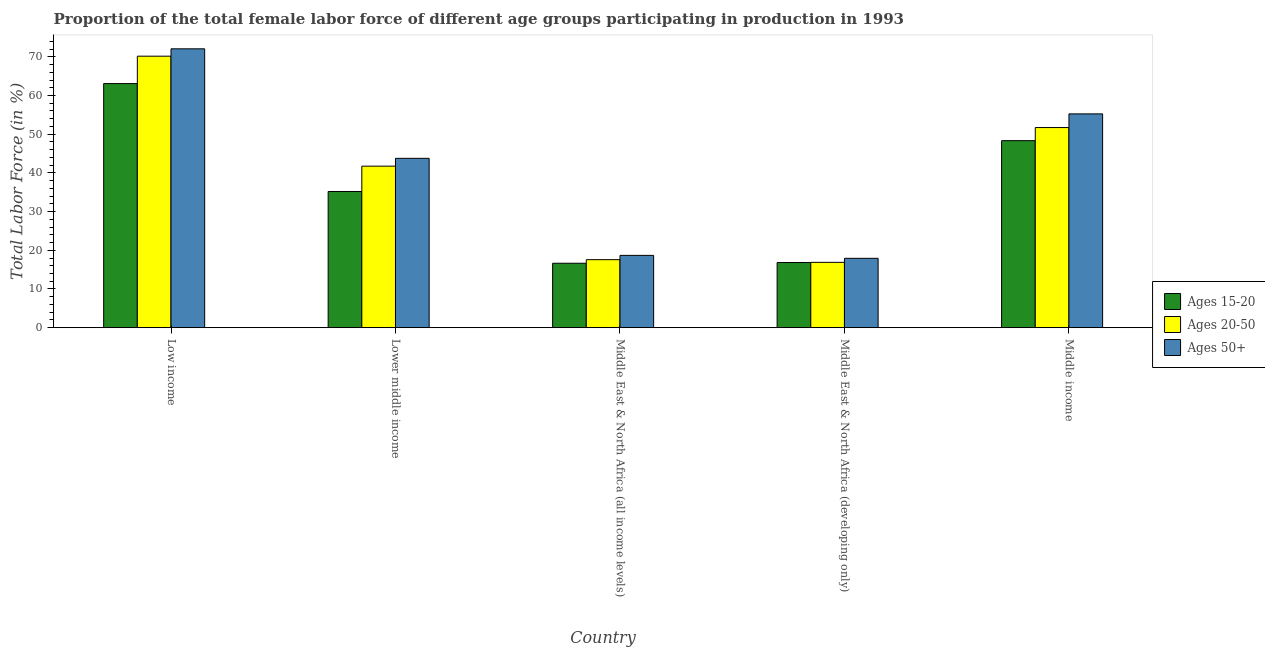How many different coloured bars are there?
Your answer should be very brief. 3. Are the number of bars per tick equal to the number of legend labels?
Your answer should be compact. Yes. What is the label of the 2nd group of bars from the left?
Your answer should be compact. Lower middle income. In how many cases, is the number of bars for a given country not equal to the number of legend labels?
Make the answer very short. 0. What is the percentage of female labor force within the age group 15-20 in Middle East & North Africa (developing only)?
Provide a succinct answer. 16.83. Across all countries, what is the maximum percentage of female labor force within the age group 15-20?
Give a very brief answer. 63.08. Across all countries, what is the minimum percentage of female labor force within the age group 15-20?
Provide a short and direct response. 16.65. In which country was the percentage of female labor force within the age group 20-50 minimum?
Provide a short and direct response. Middle East & North Africa (developing only). What is the total percentage of female labor force above age 50 in the graph?
Offer a terse response. 207.65. What is the difference between the percentage of female labor force within the age group 20-50 in Middle East & North Africa (all income levels) and that in Middle East & North Africa (developing only)?
Your response must be concise. 0.69. What is the difference between the percentage of female labor force above age 50 in Low income and the percentage of female labor force within the age group 15-20 in Middle East & North Africa (developing only)?
Offer a terse response. 55.23. What is the average percentage of female labor force within the age group 15-20 per country?
Give a very brief answer. 36.01. What is the difference between the percentage of female labor force above age 50 and percentage of female labor force within the age group 15-20 in Middle income?
Your response must be concise. 6.92. What is the ratio of the percentage of female labor force within the age group 20-50 in Low income to that in Middle East & North Africa (developing only)?
Your answer should be very brief. 4.16. What is the difference between the highest and the second highest percentage of female labor force within the age group 15-20?
Your answer should be very brief. 14.75. What is the difference between the highest and the lowest percentage of female labor force within the age group 15-20?
Your response must be concise. 46.43. Is the sum of the percentage of female labor force above age 50 in Middle East & North Africa (all income levels) and Middle income greater than the maximum percentage of female labor force within the age group 15-20 across all countries?
Provide a short and direct response. Yes. What does the 1st bar from the left in Lower middle income represents?
Give a very brief answer. Ages 15-20. What does the 3rd bar from the right in Low income represents?
Offer a very short reply. Ages 15-20. Is it the case that in every country, the sum of the percentage of female labor force within the age group 15-20 and percentage of female labor force within the age group 20-50 is greater than the percentage of female labor force above age 50?
Keep it short and to the point. Yes. How many bars are there?
Ensure brevity in your answer.  15. How many countries are there in the graph?
Offer a very short reply. 5. Are the values on the major ticks of Y-axis written in scientific E-notation?
Offer a very short reply. No. Does the graph contain grids?
Keep it short and to the point. No. How are the legend labels stacked?
Your answer should be very brief. Vertical. What is the title of the graph?
Your answer should be very brief. Proportion of the total female labor force of different age groups participating in production in 1993. Does "Central government" appear as one of the legend labels in the graph?
Provide a short and direct response. No. What is the label or title of the X-axis?
Ensure brevity in your answer.  Country. What is the label or title of the Y-axis?
Provide a short and direct response. Total Labor Force (in %). What is the Total Labor Force (in %) in Ages 15-20 in Low income?
Your answer should be compact. 63.08. What is the Total Labor Force (in %) in Ages 20-50 in Low income?
Ensure brevity in your answer.  70.16. What is the Total Labor Force (in %) of Ages 50+ in Low income?
Your response must be concise. 72.06. What is the Total Labor Force (in %) in Ages 15-20 in Lower middle income?
Your answer should be very brief. 35.19. What is the Total Labor Force (in %) of Ages 20-50 in Lower middle income?
Ensure brevity in your answer.  41.74. What is the Total Labor Force (in %) in Ages 50+ in Lower middle income?
Offer a very short reply. 43.76. What is the Total Labor Force (in %) in Ages 15-20 in Middle East & North Africa (all income levels)?
Your answer should be compact. 16.65. What is the Total Labor Force (in %) of Ages 20-50 in Middle East & North Africa (all income levels)?
Give a very brief answer. 17.57. What is the Total Labor Force (in %) of Ages 50+ in Middle East & North Africa (all income levels)?
Offer a very short reply. 18.68. What is the Total Labor Force (in %) in Ages 15-20 in Middle East & North Africa (developing only)?
Your response must be concise. 16.83. What is the Total Labor Force (in %) of Ages 20-50 in Middle East & North Africa (developing only)?
Make the answer very short. 16.88. What is the Total Labor Force (in %) in Ages 50+ in Middle East & North Africa (developing only)?
Make the answer very short. 17.92. What is the Total Labor Force (in %) in Ages 15-20 in Middle income?
Offer a terse response. 48.32. What is the Total Labor Force (in %) in Ages 20-50 in Middle income?
Give a very brief answer. 51.71. What is the Total Labor Force (in %) of Ages 50+ in Middle income?
Offer a terse response. 55.24. Across all countries, what is the maximum Total Labor Force (in %) in Ages 15-20?
Provide a short and direct response. 63.08. Across all countries, what is the maximum Total Labor Force (in %) of Ages 20-50?
Offer a very short reply. 70.16. Across all countries, what is the maximum Total Labor Force (in %) in Ages 50+?
Offer a terse response. 72.06. Across all countries, what is the minimum Total Labor Force (in %) of Ages 15-20?
Offer a very short reply. 16.65. Across all countries, what is the minimum Total Labor Force (in %) in Ages 20-50?
Your answer should be very brief. 16.88. Across all countries, what is the minimum Total Labor Force (in %) in Ages 50+?
Your answer should be very brief. 17.92. What is the total Total Labor Force (in %) of Ages 15-20 in the graph?
Provide a succinct answer. 180.07. What is the total Total Labor Force (in %) of Ages 20-50 in the graph?
Offer a very short reply. 198.06. What is the total Total Labor Force (in %) in Ages 50+ in the graph?
Make the answer very short. 207.65. What is the difference between the Total Labor Force (in %) in Ages 15-20 in Low income and that in Lower middle income?
Your answer should be compact. 27.89. What is the difference between the Total Labor Force (in %) of Ages 20-50 in Low income and that in Lower middle income?
Provide a succinct answer. 28.42. What is the difference between the Total Labor Force (in %) in Ages 50+ in Low income and that in Lower middle income?
Provide a succinct answer. 28.3. What is the difference between the Total Labor Force (in %) in Ages 15-20 in Low income and that in Middle East & North Africa (all income levels)?
Your response must be concise. 46.43. What is the difference between the Total Labor Force (in %) of Ages 20-50 in Low income and that in Middle East & North Africa (all income levels)?
Keep it short and to the point. 52.59. What is the difference between the Total Labor Force (in %) in Ages 50+ in Low income and that in Middle East & North Africa (all income levels)?
Your response must be concise. 53.38. What is the difference between the Total Labor Force (in %) of Ages 15-20 in Low income and that in Middle East & North Africa (developing only)?
Give a very brief answer. 46.25. What is the difference between the Total Labor Force (in %) of Ages 20-50 in Low income and that in Middle East & North Africa (developing only)?
Give a very brief answer. 53.28. What is the difference between the Total Labor Force (in %) in Ages 50+ in Low income and that in Middle East & North Africa (developing only)?
Offer a terse response. 54.14. What is the difference between the Total Labor Force (in %) in Ages 15-20 in Low income and that in Middle income?
Offer a terse response. 14.75. What is the difference between the Total Labor Force (in %) of Ages 20-50 in Low income and that in Middle income?
Your answer should be very brief. 18.45. What is the difference between the Total Labor Force (in %) in Ages 50+ in Low income and that in Middle income?
Your answer should be very brief. 16.81. What is the difference between the Total Labor Force (in %) of Ages 15-20 in Lower middle income and that in Middle East & North Africa (all income levels)?
Your response must be concise. 18.54. What is the difference between the Total Labor Force (in %) of Ages 20-50 in Lower middle income and that in Middle East & North Africa (all income levels)?
Provide a succinct answer. 24.17. What is the difference between the Total Labor Force (in %) in Ages 50+ in Lower middle income and that in Middle East & North Africa (all income levels)?
Provide a short and direct response. 25.08. What is the difference between the Total Labor Force (in %) in Ages 15-20 in Lower middle income and that in Middle East & North Africa (developing only)?
Give a very brief answer. 18.36. What is the difference between the Total Labor Force (in %) in Ages 20-50 in Lower middle income and that in Middle East & North Africa (developing only)?
Ensure brevity in your answer.  24.86. What is the difference between the Total Labor Force (in %) of Ages 50+ in Lower middle income and that in Middle East & North Africa (developing only)?
Your answer should be compact. 25.84. What is the difference between the Total Labor Force (in %) of Ages 15-20 in Lower middle income and that in Middle income?
Keep it short and to the point. -13.14. What is the difference between the Total Labor Force (in %) of Ages 20-50 in Lower middle income and that in Middle income?
Provide a short and direct response. -9.97. What is the difference between the Total Labor Force (in %) of Ages 50+ in Lower middle income and that in Middle income?
Make the answer very short. -11.49. What is the difference between the Total Labor Force (in %) in Ages 15-20 in Middle East & North Africa (all income levels) and that in Middle East & North Africa (developing only)?
Offer a terse response. -0.18. What is the difference between the Total Labor Force (in %) of Ages 20-50 in Middle East & North Africa (all income levels) and that in Middle East & North Africa (developing only)?
Provide a succinct answer. 0.69. What is the difference between the Total Labor Force (in %) of Ages 50+ in Middle East & North Africa (all income levels) and that in Middle East & North Africa (developing only)?
Your answer should be very brief. 0.76. What is the difference between the Total Labor Force (in %) of Ages 15-20 in Middle East & North Africa (all income levels) and that in Middle income?
Give a very brief answer. -31.68. What is the difference between the Total Labor Force (in %) of Ages 20-50 in Middle East & North Africa (all income levels) and that in Middle income?
Provide a short and direct response. -34.14. What is the difference between the Total Labor Force (in %) in Ages 50+ in Middle East & North Africa (all income levels) and that in Middle income?
Provide a short and direct response. -36.57. What is the difference between the Total Labor Force (in %) of Ages 15-20 in Middle East & North Africa (developing only) and that in Middle income?
Provide a short and direct response. -31.49. What is the difference between the Total Labor Force (in %) of Ages 20-50 in Middle East & North Africa (developing only) and that in Middle income?
Your response must be concise. -34.83. What is the difference between the Total Labor Force (in %) in Ages 50+ in Middle East & North Africa (developing only) and that in Middle income?
Give a very brief answer. -37.32. What is the difference between the Total Labor Force (in %) of Ages 15-20 in Low income and the Total Labor Force (in %) of Ages 20-50 in Lower middle income?
Provide a succinct answer. 21.34. What is the difference between the Total Labor Force (in %) of Ages 15-20 in Low income and the Total Labor Force (in %) of Ages 50+ in Lower middle income?
Give a very brief answer. 19.32. What is the difference between the Total Labor Force (in %) in Ages 20-50 in Low income and the Total Labor Force (in %) in Ages 50+ in Lower middle income?
Your answer should be very brief. 26.4. What is the difference between the Total Labor Force (in %) in Ages 15-20 in Low income and the Total Labor Force (in %) in Ages 20-50 in Middle East & North Africa (all income levels)?
Your response must be concise. 45.51. What is the difference between the Total Labor Force (in %) in Ages 15-20 in Low income and the Total Labor Force (in %) in Ages 50+ in Middle East & North Africa (all income levels)?
Your response must be concise. 44.4. What is the difference between the Total Labor Force (in %) in Ages 20-50 in Low income and the Total Labor Force (in %) in Ages 50+ in Middle East & North Africa (all income levels)?
Your answer should be compact. 51.48. What is the difference between the Total Labor Force (in %) in Ages 15-20 in Low income and the Total Labor Force (in %) in Ages 20-50 in Middle East & North Africa (developing only)?
Give a very brief answer. 46.2. What is the difference between the Total Labor Force (in %) of Ages 15-20 in Low income and the Total Labor Force (in %) of Ages 50+ in Middle East & North Africa (developing only)?
Offer a terse response. 45.16. What is the difference between the Total Labor Force (in %) of Ages 20-50 in Low income and the Total Labor Force (in %) of Ages 50+ in Middle East & North Africa (developing only)?
Keep it short and to the point. 52.24. What is the difference between the Total Labor Force (in %) of Ages 15-20 in Low income and the Total Labor Force (in %) of Ages 20-50 in Middle income?
Offer a very short reply. 11.37. What is the difference between the Total Labor Force (in %) in Ages 15-20 in Low income and the Total Labor Force (in %) in Ages 50+ in Middle income?
Give a very brief answer. 7.83. What is the difference between the Total Labor Force (in %) in Ages 20-50 in Low income and the Total Labor Force (in %) in Ages 50+ in Middle income?
Your answer should be very brief. 14.91. What is the difference between the Total Labor Force (in %) of Ages 15-20 in Lower middle income and the Total Labor Force (in %) of Ages 20-50 in Middle East & North Africa (all income levels)?
Your answer should be compact. 17.62. What is the difference between the Total Labor Force (in %) in Ages 15-20 in Lower middle income and the Total Labor Force (in %) in Ages 50+ in Middle East & North Africa (all income levels)?
Offer a terse response. 16.51. What is the difference between the Total Labor Force (in %) of Ages 20-50 in Lower middle income and the Total Labor Force (in %) of Ages 50+ in Middle East & North Africa (all income levels)?
Provide a succinct answer. 23.06. What is the difference between the Total Labor Force (in %) of Ages 15-20 in Lower middle income and the Total Labor Force (in %) of Ages 20-50 in Middle East & North Africa (developing only)?
Keep it short and to the point. 18.31. What is the difference between the Total Labor Force (in %) of Ages 15-20 in Lower middle income and the Total Labor Force (in %) of Ages 50+ in Middle East & North Africa (developing only)?
Keep it short and to the point. 17.27. What is the difference between the Total Labor Force (in %) in Ages 20-50 in Lower middle income and the Total Labor Force (in %) in Ages 50+ in Middle East & North Africa (developing only)?
Give a very brief answer. 23.82. What is the difference between the Total Labor Force (in %) in Ages 15-20 in Lower middle income and the Total Labor Force (in %) in Ages 20-50 in Middle income?
Offer a terse response. -16.52. What is the difference between the Total Labor Force (in %) in Ages 15-20 in Lower middle income and the Total Labor Force (in %) in Ages 50+ in Middle income?
Provide a succinct answer. -20.06. What is the difference between the Total Labor Force (in %) of Ages 20-50 in Lower middle income and the Total Labor Force (in %) of Ages 50+ in Middle income?
Give a very brief answer. -13.5. What is the difference between the Total Labor Force (in %) in Ages 15-20 in Middle East & North Africa (all income levels) and the Total Labor Force (in %) in Ages 20-50 in Middle East & North Africa (developing only)?
Offer a very short reply. -0.23. What is the difference between the Total Labor Force (in %) of Ages 15-20 in Middle East & North Africa (all income levels) and the Total Labor Force (in %) of Ages 50+ in Middle East & North Africa (developing only)?
Offer a terse response. -1.27. What is the difference between the Total Labor Force (in %) of Ages 20-50 in Middle East & North Africa (all income levels) and the Total Labor Force (in %) of Ages 50+ in Middle East & North Africa (developing only)?
Offer a terse response. -0.35. What is the difference between the Total Labor Force (in %) in Ages 15-20 in Middle East & North Africa (all income levels) and the Total Labor Force (in %) in Ages 20-50 in Middle income?
Offer a very short reply. -35.06. What is the difference between the Total Labor Force (in %) of Ages 15-20 in Middle East & North Africa (all income levels) and the Total Labor Force (in %) of Ages 50+ in Middle income?
Give a very brief answer. -38.6. What is the difference between the Total Labor Force (in %) in Ages 20-50 in Middle East & North Africa (all income levels) and the Total Labor Force (in %) in Ages 50+ in Middle income?
Your response must be concise. -37.67. What is the difference between the Total Labor Force (in %) in Ages 15-20 in Middle East & North Africa (developing only) and the Total Labor Force (in %) in Ages 20-50 in Middle income?
Provide a succinct answer. -34.88. What is the difference between the Total Labor Force (in %) of Ages 15-20 in Middle East & North Africa (developing only) and the Total Labor Force (in %) of Ages 50+ in Middle income?
Your response must be concise. -38.41. What is the difference between the Total Labor Force (in %) of Ages 20-50 in Middle East & North Africa (developing only) and the Total Labor Force (in %) of Ages 50+ in Middle income?
Offer a very short reply. -38.37. What is the average Total Labor Force (in %) in Ages 15-20 per country?
Provide a succinct answer. 36.01. What is the average Total Labor Force (in %) in Ages 20-50 per country?
Offer a very short reply. 39.61. What is the average Total Labor Force (in %) in Ages 50+ per country?
Provide a succinct answer. 41.53. What is the difference between the Total Labor Force (in %) of Ages 15-20 and Total Labor Force (in %) of Ages 20-50 in Low income?
Keep it short and to the point. -7.08. What is the difference between the Total Labor Force (in %) of Ages 15-20 and Total Labor Force (in %) of Ages 50+ in Low income?
Make the answer very short. -8.98. What is the difference between the Total Labor Force (in %) in Ages 20-50 and Total Labor Force (in %) in Ages 50+ in Low income?
Make the answer very short. -1.9. What is the difference between the Total Labor Force (in %) in Ages 15-20 and Total Labor Force (in %) in Ages 20-50 in Lower middle income?
Your answer should be very brief. -6.55. What is the difference between the Total Labor Force (in %) in Ages 15-20 and Total Labor Force (in %) in Ages 50+ in Lower middle income?
Give a very brief answer. -8.57. What is the difference between the Total Labor Force (in %) of Ages 20-50 and Total Labor Force (in %) of Ages 50+ in Lower middle income?
Keep it short and to the point. -2.02. What is the difference between the Total Labor Force (in %) in Ages 15-20 and Total Labor Force (in %) in Ages 20-50 in Middle East & North Africa (all income levels)?
Offer a terse response. -0.92. What is the difference between the Total Labor Force (in %) in Ages 15-20 and Total Labor Force (in %) in Ages 50+ in Middle East & North Africa (all income levels)?
Ensure brevity in your answer.  -2.03. What is the difference between the Total Labor Force (in %) in Ages 20-50 and Total Labor Force (in %) in Ages 50+ in Middle East & North Africa (all income levels)?
Your response must be concise. -1.11. What is the difference between the Total Labor Force (in %) of Ages 15-20 and Total Labor Force (in %) of Ages 20-50 in Middle East & North Africa (developing only)?
Your answer should be compact. -0.05. What is the difference between the Total Labor Force (in %) of Ages 15-20 and Total Labor Force (in %) of Ages 50+ in Middle East & North Africa (developing only)?
Give a very brief answer. -1.09. What is the difference between the Total Labor Force (in %) in Ages 20-50 and Total Labor Force (in %) in Ages 50+ in Middle East & North Africa (developing only)?
Your answer should be very brief. -1.04. What is the difference between the Total Labor Force (in %) of Ages 15-20 and Total Labor Force (in %) of Ages 20-50 in Middle income?
Make the answer very short. -3.39. What is the difference between the Total Labor Force (in %) in Ages 15-20 and Total Labor Force (in %) in Ages 50+ in Middle income?
Offer a very short reply. -6.92. What is the difference between the Total Labor Force (in %) of Ages 20-50 and Total Labor Force (in %) of Ages 50+ in Middle income?
Your answer should be very brief. -3.53. What is the ratio of the Total Labor Force (in %) in Ages 15-20 in Low income to that in Lower middle income?
Keep it short and to the point. 1.79. What is the ratio of the Total Labor Force (in %) in Ages 20-50 in Low income to that in Lower middle income?
Your answer should be very brief. 1.68. What is the ratio of the Total Labor Force (in %) in Ages 50+ in Low income to that in Lower middle income?
Make the answer very short. 1.65. What is the ratio of the Total Labor Force (in %) of Ages 15-20 in Low income to that in Middle East & North Africa (all income levels)?
Give a very brief answer. 3.79. What is the ratio of the Total Labor Force (in %) in Ages 20-50 in Low income to that in Middle East & North Africa (all income levels)?
Keep it short and to the point. 3.99. What is the ratio of the Total Labor Force (in %) in Ages 50+ in Low income to that in Middle East & North Africa (all income levels)?
Offer a very short reply. 3.86. What is the ratio of the Total Labor Force (in %) of Ages 15-20 in Low income to that in Middle East & North Africa (developing only)?
Your answer should be compact. 3.75. What is the ratio of the Total Labor Force (in %) of Ages 20-50 in Low income to that in Middle East & North Africa (developing only)?
Offer a very short reply. 4.16. What is the ratio of the Total Labor Force (in %) in Ages 50+ in Low income to that in Middle East & North Africa (developing only)?
Your answer should be very brief. 4.02. What is the ratio of the Total Labor Force (in %) of Ages 15-20 in Low income to that in Middle income?
Your answer should be very brief. 1.31. What is the ratio of the Total Labor Force (in %) of Ages 20-50 in Low income to that in Middle income?
Your answer should be compact. 1.36. What is the ratio of the Total Labor Force (in %) of Ages 50+ in Low income to that in Middle income?
Your answer should be compact. 1.3. What is the ratio of the Total Labor Force (in %) in Ages 15-20 in Lower middle income to that in Middle East & North Africa (all income levels)?
Make the answer very short. 2.11. What is the ratio of the Total Labor Force (in %) of Ages 20-50 in Lower middle income to that in Middle East & North Africa (all income levels)?
Keep it short and to the point. 2.38. What is the ratio of the Total Labor Force (in %) of Ages 50+ in Lower middle income to that in Middle East & North Africa (all income levels)?
Offer a very short reply. 2.34. What is the ratio of the Total Labor Force (in %) in Ages 15-20 in Lower middle income to that in Middle East & North Africa (developing only)?
Make the answer very short. 2.09. What is the ratio of the Total Labor Force (in %) in Ages 20-50 in Lower middle income to that in Middle East & North Africa (developing only)?
Give a very brief answer. 2.47. What is the ratio of the Total Labor Force (in %) of Ages 50+ in Lower middle income to that in Middle East & North Africa (developing only)?
Your answer should be very brief. 2.44. What is the ratio of the Total Labor Force (in %) of Ages 15-20 in Lower middle income to that in Middle income?
Offer a very short reply. 0.73. What is the ratio of the Total Labor Force (in %) of Ages 20-50 in Lower middle income to that in Middle income?
Your answer should be compact. 0.81. What is the ratio of the Total Labor Force (in %) in Ages 50+ in Lower middle income to that in Middle income?
Offer a very short reply. 0.79. What is the ratio of the Total Labor Force (in %) of Ages 20-50 in Middle East & North Africa (all income levels) to that in Middle East & North Africa (developing only)?
Offer a very short reply. 1.04. What is the ratio of the Total Labor Force (in %) in Ages 50+ in Middle East & North Africa (all income levels) to that in Middle East & North Africa (developing only)?
Ensure brevity in your answer.  1.04. What is the ratio of the Total Labor Force (in %) of Ages 15-20 in Middle East & North Africa (all income levels) to that in Middle income?
Offer a very short reply. 0.34. What is the ratio of the Total Labor Force (in %) in Ages 20-50 in Middle East & North Africa (all income levels) to that in Middle income?
Your answer should be compact. 0.34. What is the ratio of the Total Labor Force (in %) in Ages 50+ in Middle East & North Africa (all income levels) to that in Middle income?
Offer a terse response. 0.34. What is the ratio of the Total Labor Force (in %) of Ages 15-20 in Middle East & North Africa (developing only) to that in Middle income?
Make the answer very short. 0.35. What is the ratio of the Total Labor Force (in %) in Ages 20-50 in Middle East & North Africa (developing only) to that in Middle income?
Your answer should be compact. 0.33. What is the ratio of the Total Labor Force (in %) of Ages 50+ in Middle East & North Africa (developing only) to that in Middle income?
Provide a succinct answer. 0.32. What is the difference between the highest and the second highest Total Labor Force (in %) in Ages 15-20?
Provide a succinct answer. 14.75. What is the difference between the highest and the second highest Total Labor Force (in %) in Ages 20-50?
Keep it short and to the point. 18.45. What is the difference between the highest and the second highest Total Labor Force (in %) of Ages 50+?
Offer a terse response. 16.81. What is the difference between the highest and the lowest Total Labor Force (in %) of Ages 15-20?
Give a very brief answer. 46.43. What is the difference between the highest and the lowest Total Labor Force (in %) of Ages 20-50?
Make the answer very short. 53.28. What is the difference between the highest and the lowest Total Labor Force (in %) of Ages 50+?
Your answer should be very brief. 54.14. 